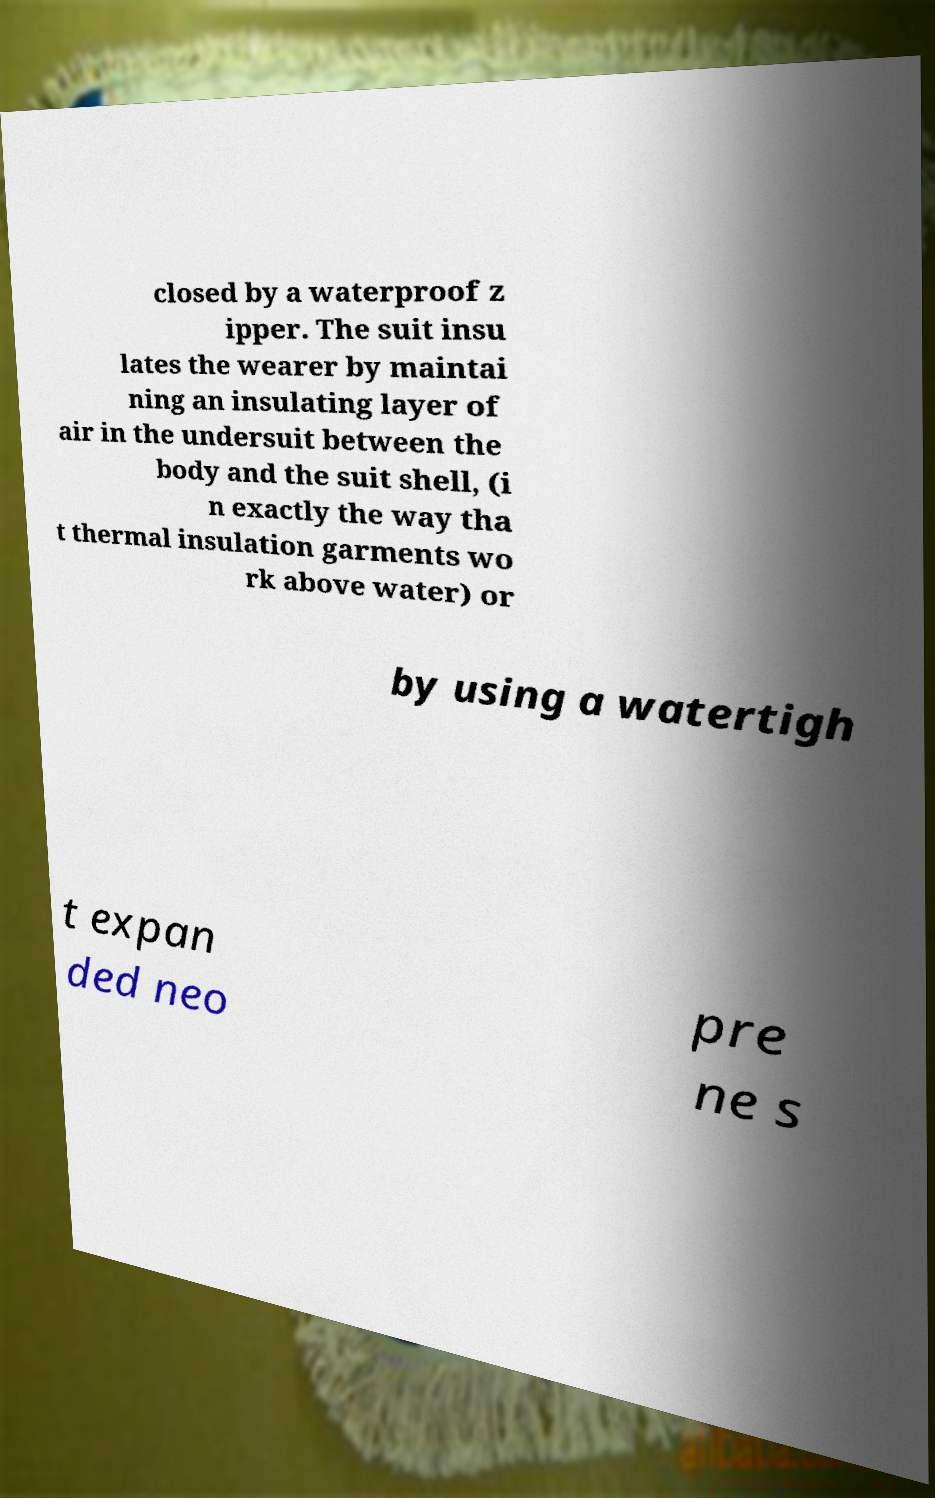What messages or text are displayed in this image? I need them in a readable, typed format. closed by a waterproof z ipper. The suit insu lates the wearer by maintai ning an insulating layer of air in the undersuit between the body and the suit shell, (i n exactly the way tha t thermal insulation garments wo rk above water) or by using a watertigh t expan ded neo pre ne s 